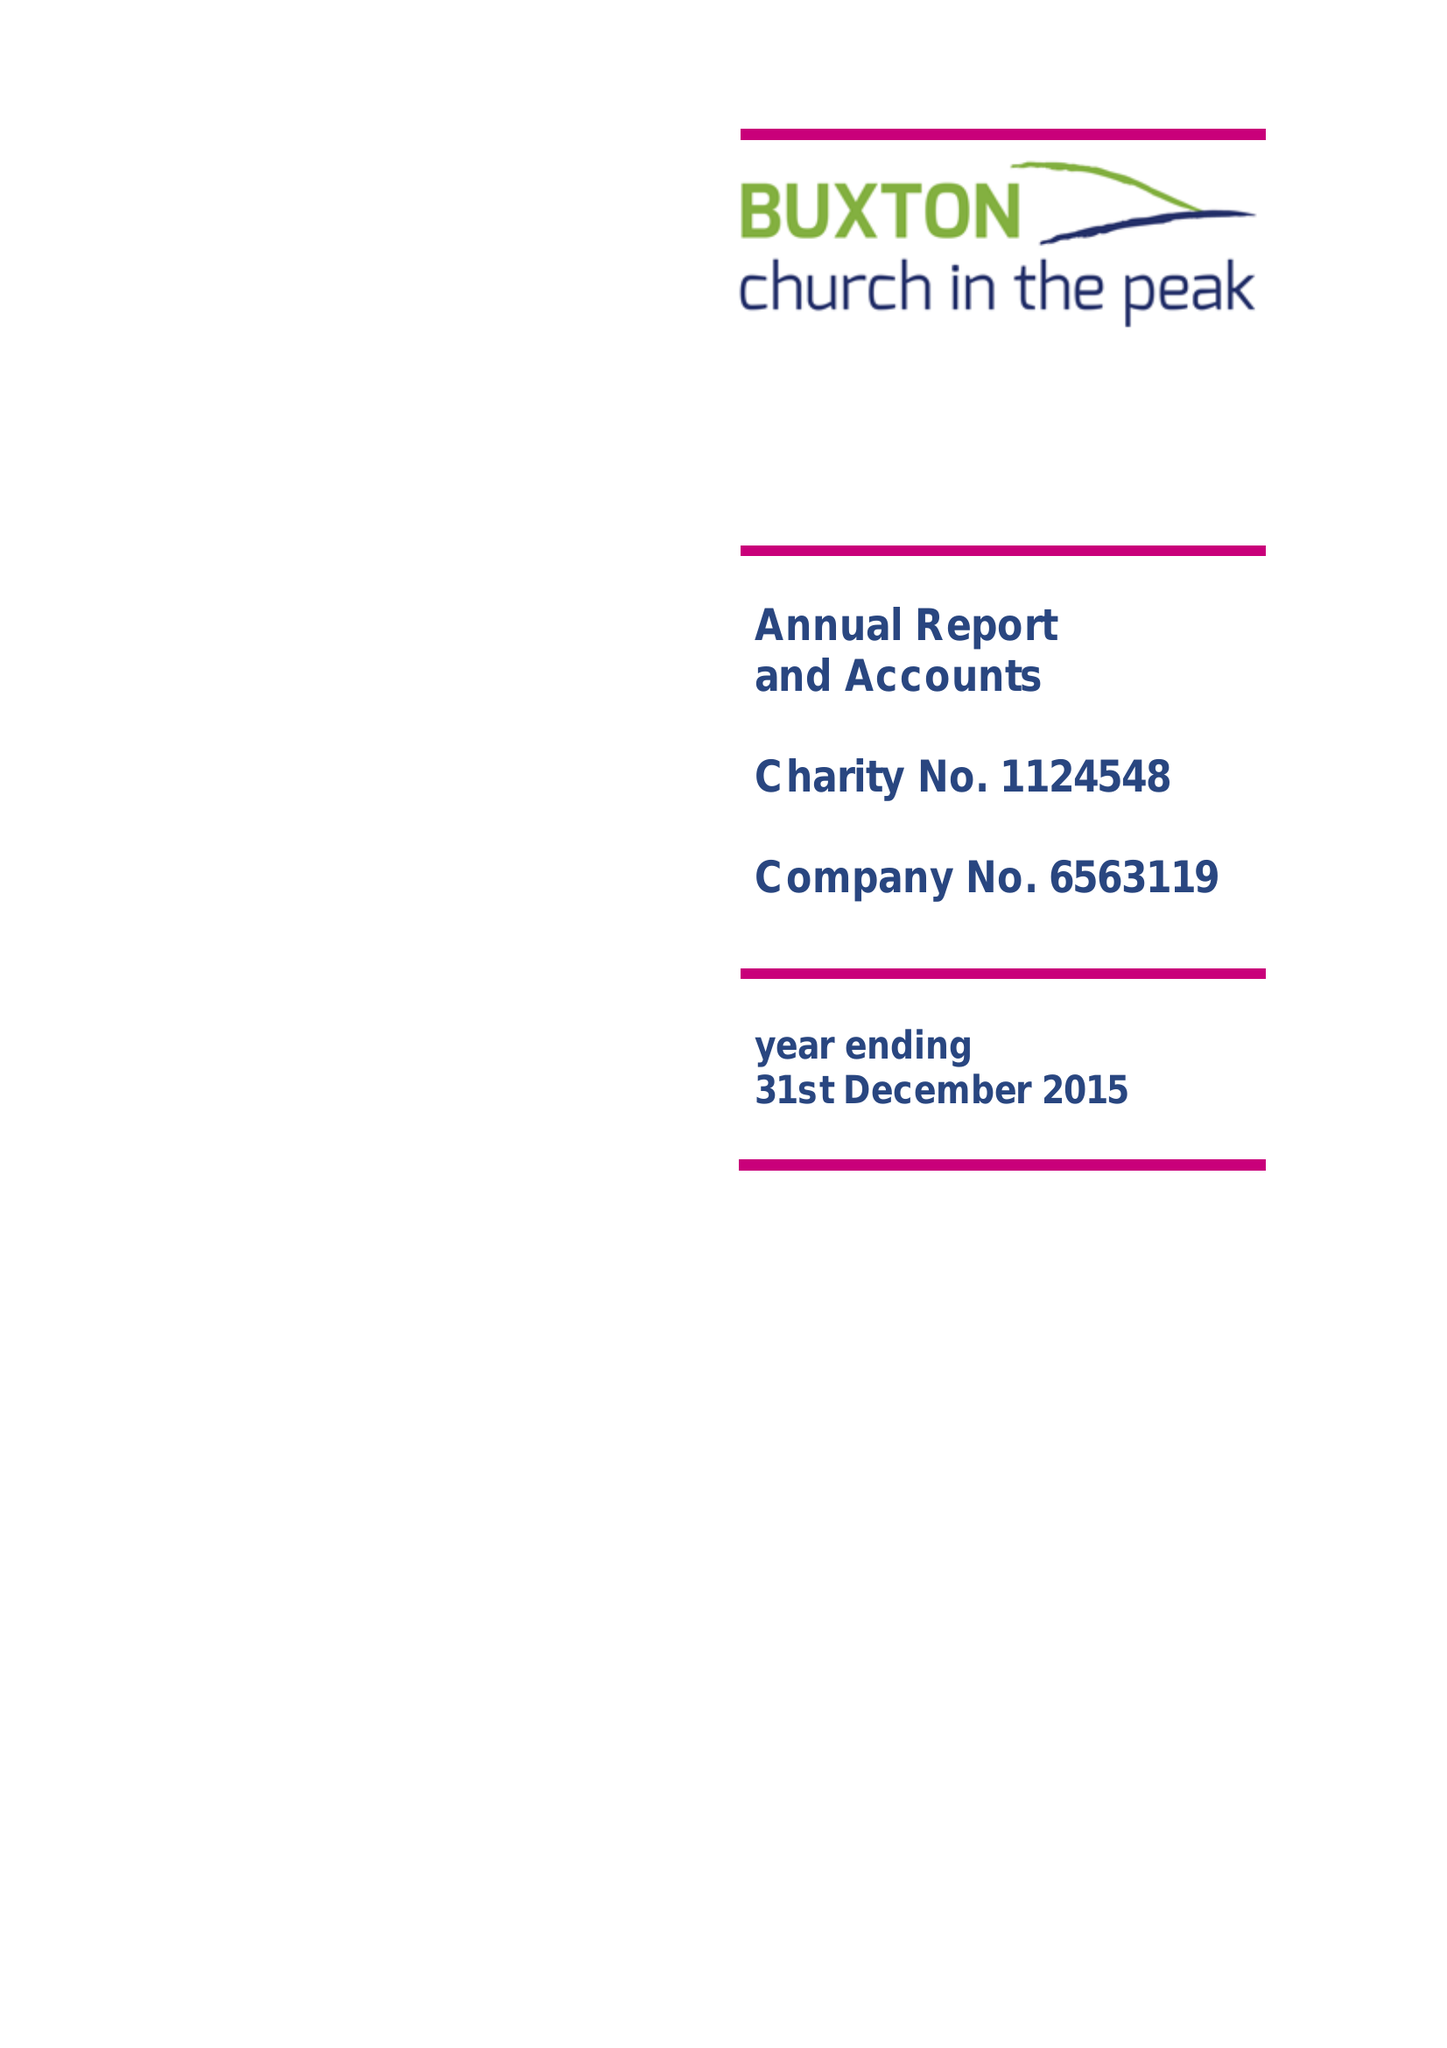What is the value for the address__post_town?
Answer the question using a single word or phrase. BUXTON 